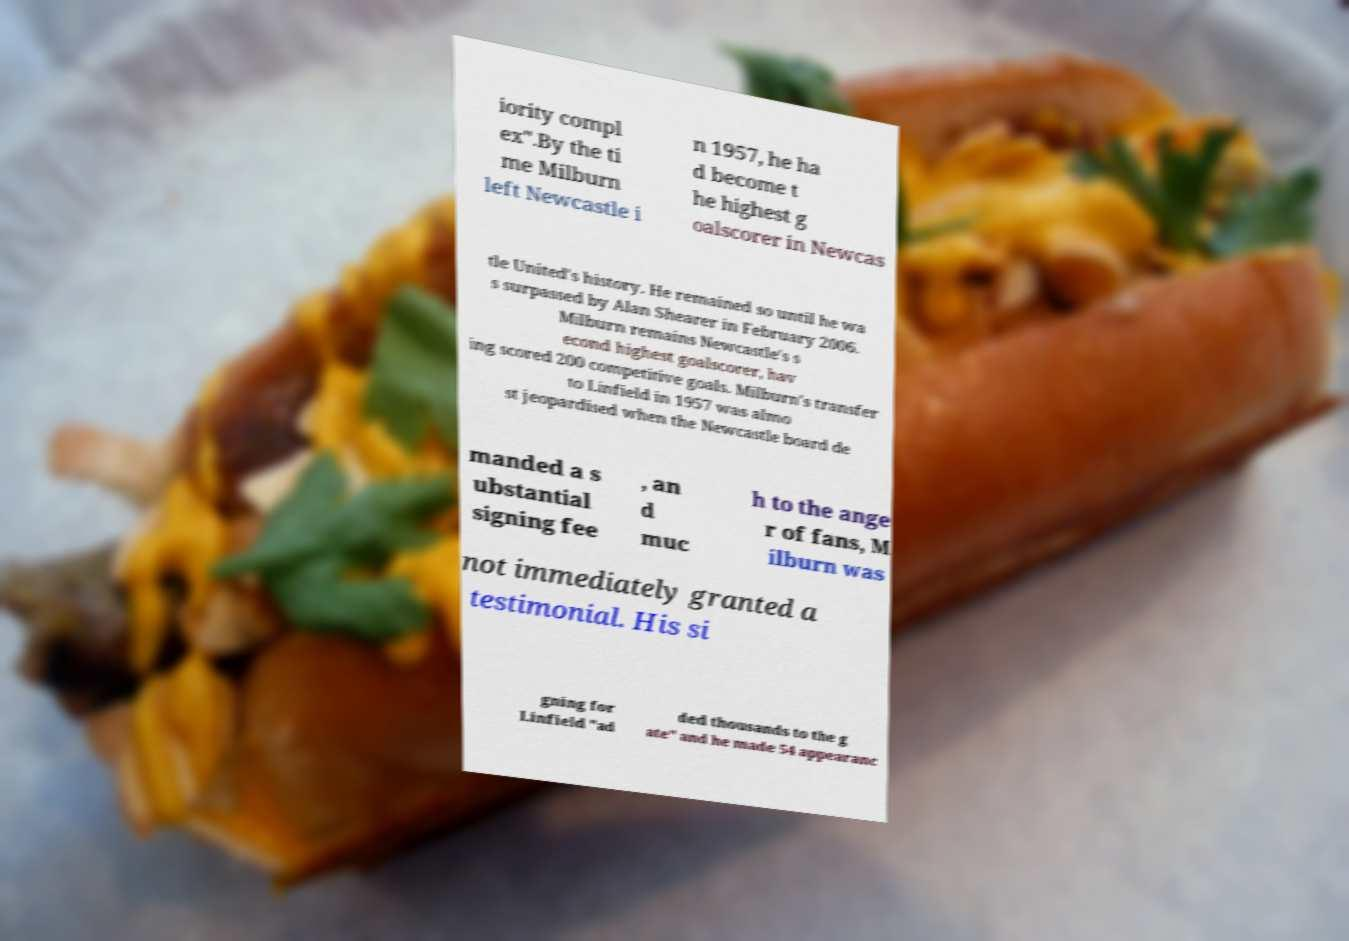I need the written content from this picture converted into text. Can you do that? iority compl ex".By the ti me Milburn left Newcastle i n 1957, he ha d become t he highest g oalscorer in Newcas tle United's history. He remained so until he wa s surpassed by Alan Shearer in February 2006. Milburn remains Newcastle's s econd highest goalscorer, hav ing scored 200 competitive goals. Milburn's transfer to Linfield in 1957 was almo st jeopardised when the Newcastle board de manded a s ubstantial signing fee , an d muc h to the ange r of fans, M ilburn was not immediately granted a testimonial. His si gning for Linfield "ad ded thousands to the g ate" and he made 54 appearanc 